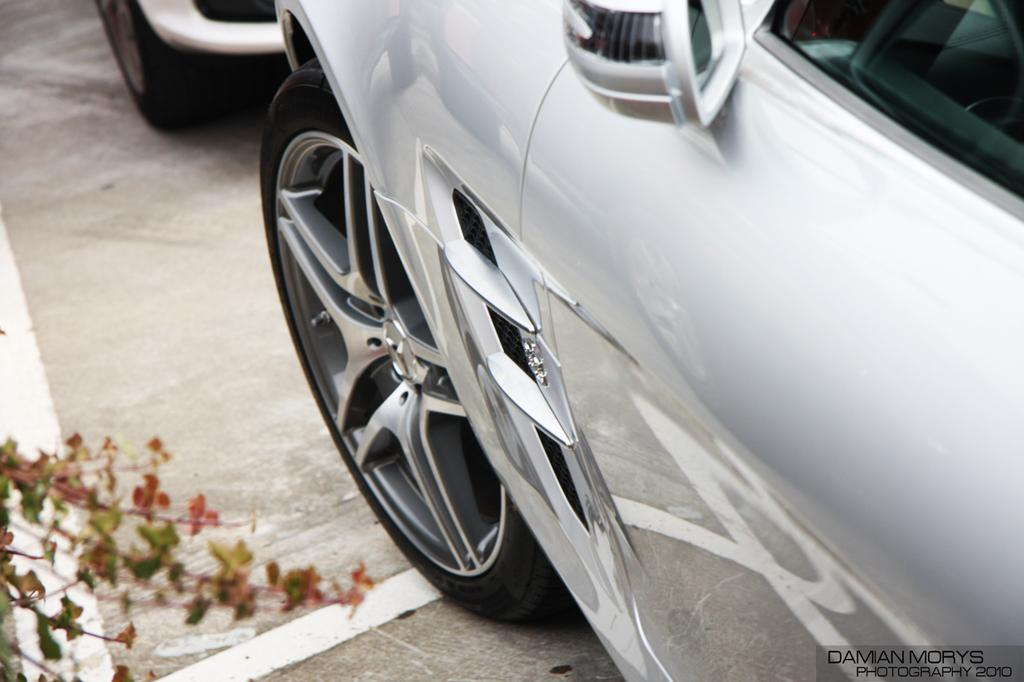How many vehicles can be seen in the image? There are two vehicles in the image. Where are the vehicles located? The vehicles are on the floor. What else is present on the left side of the image? There is a plant on the left side of the image. What time does the clock show in the image? There is no clock present in the image. What sense is being used by the vehicles in the image? Vehicles do not have senses, as they are inanimate objects. 